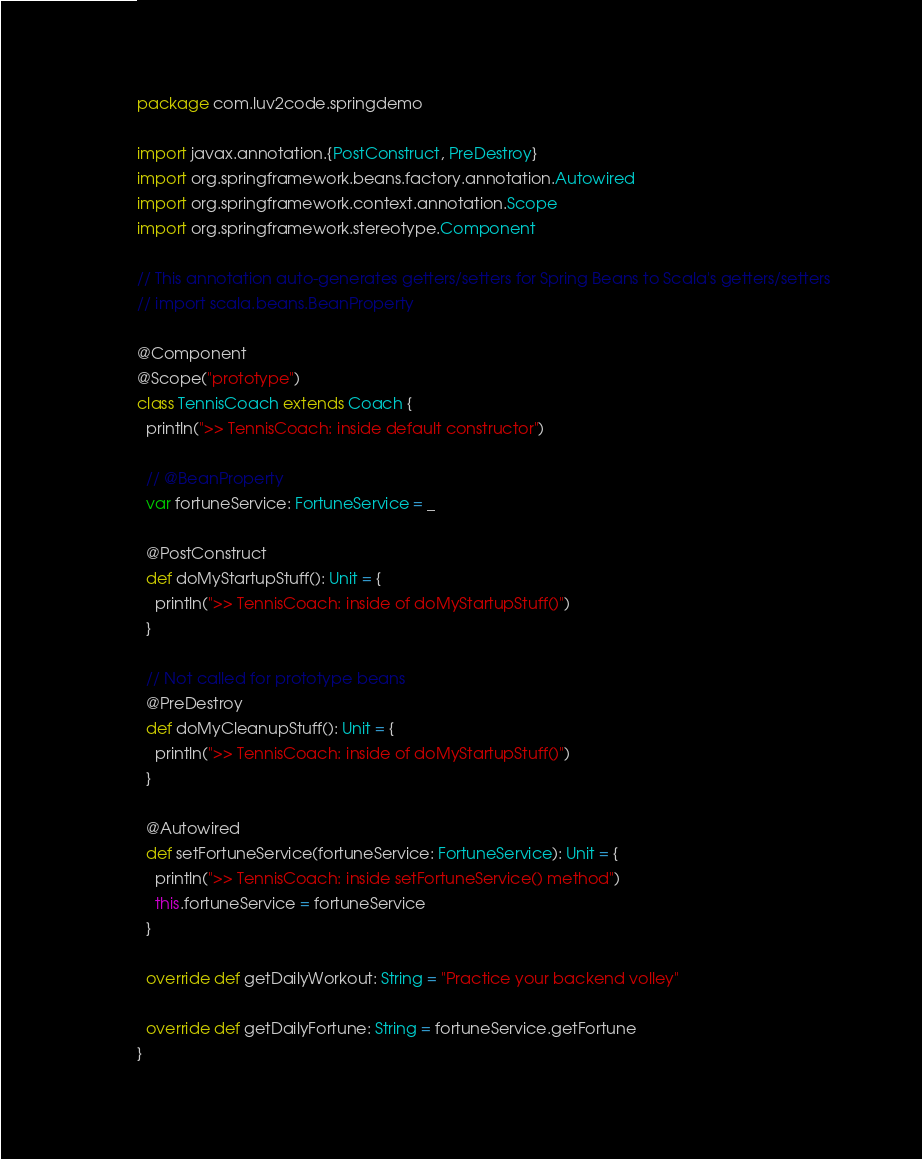Convert code to text. <code><loc_0><loc_0><loc_500><loc_500><_Scala_>package com.luv2code.springdemo

import javax.annotation.{PostConstruct, PreDestroy}
import org.springframework.beans.factory.annotation.Autowired
import org.springframework.context.annotation.Scope
import org.springframework.stereotype.Component

// This annotation auto-generates getters/setters for Spring Beans to Scala's getters/setters
// import scala.beans.BeanProperty

@Component
@Scope("prototype")
class TennisCoach extends Coach {
  println(">> TennisCoach: inside default constructor")

  // @BeanProperty
  var fortuneService: FortuneService = _

  @PostConstruct
  def doMyStartupStuff(): Unit = {
    println(">> TennisCoach: inside of doMyStartupStuff()")
  }

  // Not called for prototype beans
  @PreDestroy
  def doMyCleanupStuff(): Unit = {
    println(">> TennisCoach: inside of doMyStartupStuff()")
  }

  @Autowired
  def setFortuneService(fortuneService: FortuneService): Unit = {
    println(">> TennisCoach: inside setFortuneService() method")
    this.fortuneService = fortuneService
  }

  override def getDailyWorkout: String = "Practice your backend volley"

  override def getDailyFortune: String = fortuneService.getFortune
}
</code> 